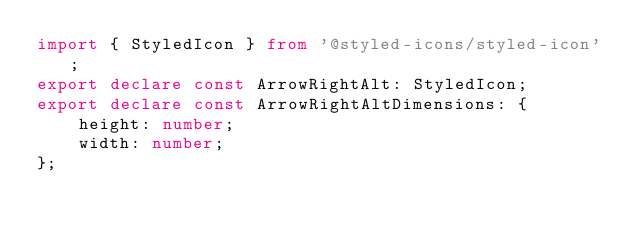Convert code to text. <code><loc_0><loc_0><loc_500><loc_500><_TypeScript_>import { StyledIcon } from '@styled-icons/styled-icon';
export declare const ArrowRightAlt: StyledIcon;
export declare const ArrowRightAltDimensions: {
    height: number;
    width: number;
};
</code> 